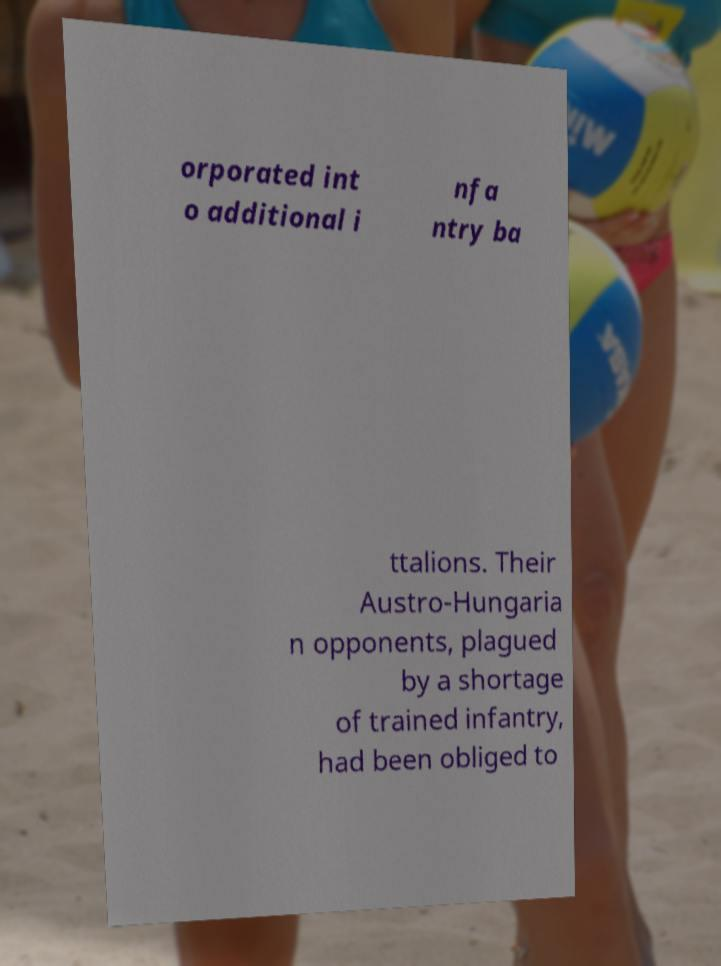Can you accurately transcribe the text from the provided image for me? orporated int o additional i nfa ntry ba ttalions. Their Austro-Hungaria n opponents, plagued by a shortage of trained infantry, had been obliged to 